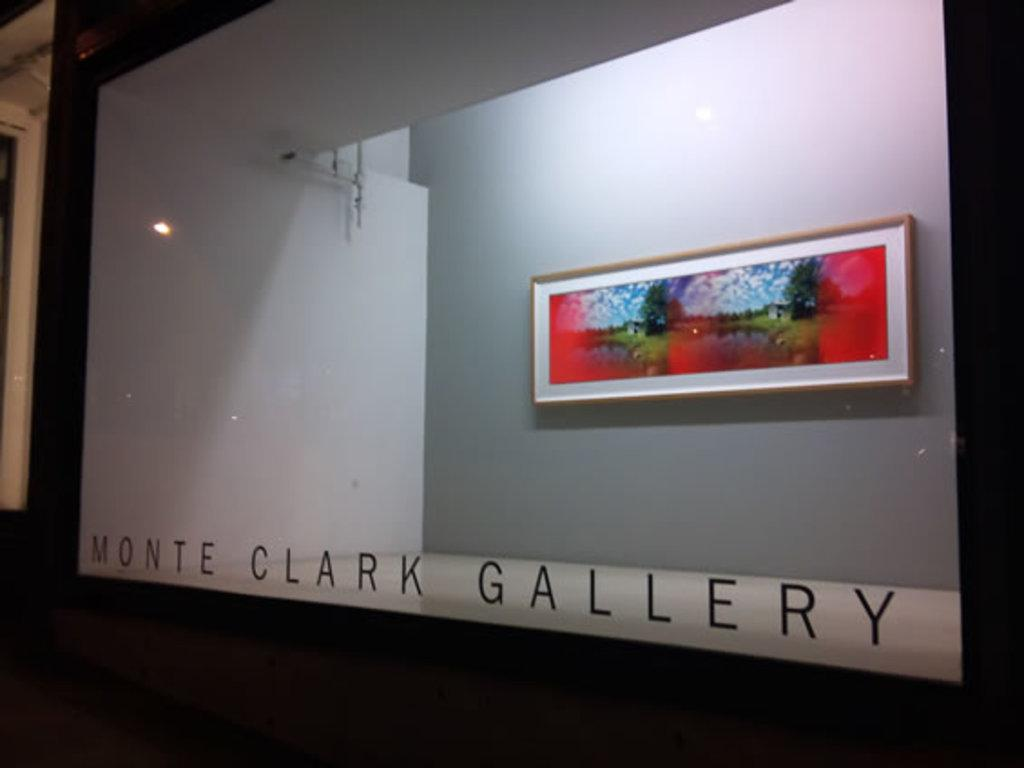<image>
Render a clear and concise summary of the photo. Art Gallery from Monte Clark, which has a picture of a landscape. 